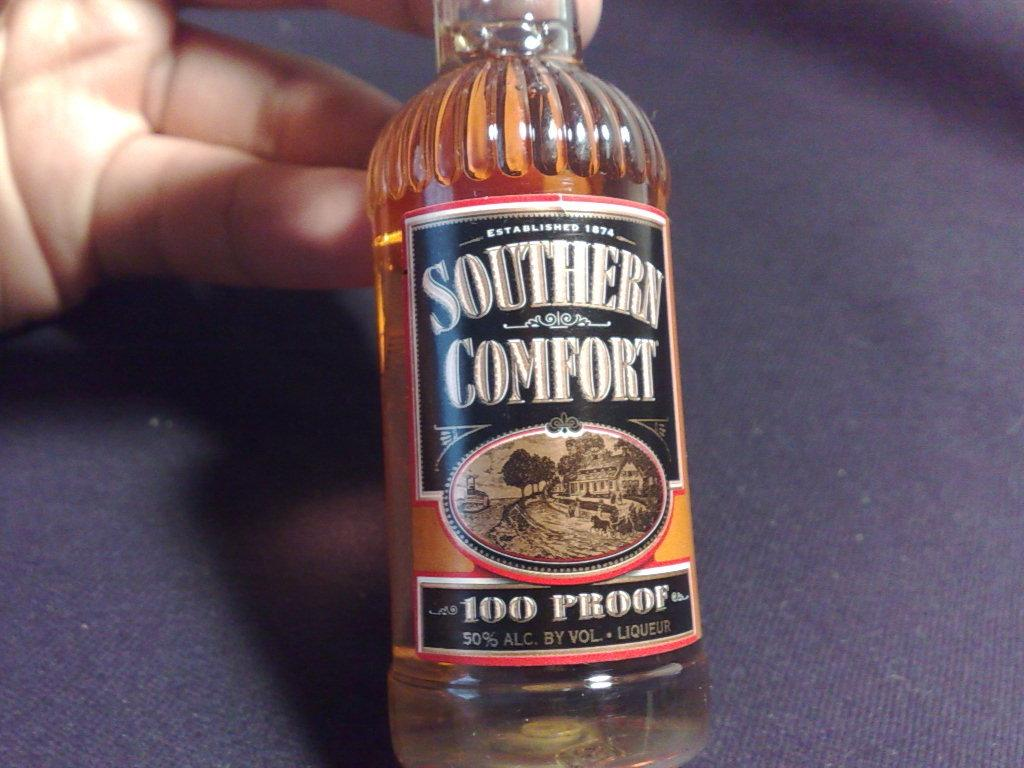<image>
Render a clear and concise summary of the photo. A person holding a mini bottle of Southern Comfort liqueur with a 50% alcoholic count in an inclined way. 